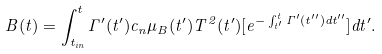Convert formula to latex. <formula><loc_0><loc_0><loc_500><loc_500>B ( t ) = { \int _ { t _ { i n } } ^ { t } { \Gamma ^ { \prime } ( t ^ { \prime } ) c _ { n } \mu _ { B } ( t ^ { \prime } ) T ^ { 2 } ( t ^ { \prime } ) [ e ^ { - \int _ { t ^ { \prime } } ^ { t } \Gamma ^ { \prime } ( t ^ { \prime \prime } ) d t ^ { \prime \prime } } ] d t ^ { \prime } } } .</formula> 